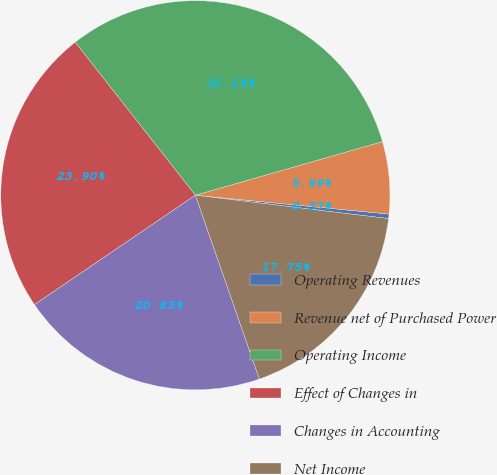Convert chart to OTSL. <chart><loc_0><loc_0><loc_500><loc_500><pie_chart><fcel>Operating Revenues<fcel>Revenue net of Purchased Power<fcel>Operating Income<fcel>Effect of Changes in<fcel>Changes in Accounting<fcel>Net Income<nl><fcel>0.37%<fcel>5.99%<fcel>31.15%<fcel>23.9%<fcel>20.83%<fcel>17.75%<nl></chart> 